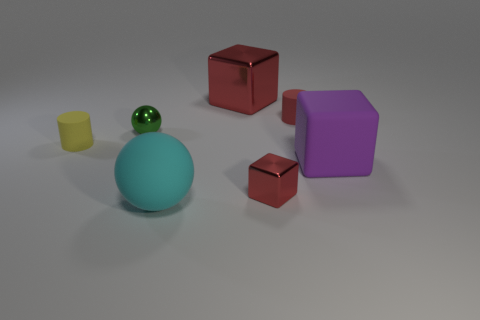What number of other things are the same shape as the tiny red rubber object? One item shares the same shape as the tiny red rubber object, which is the larger red object shaped like a cube. 